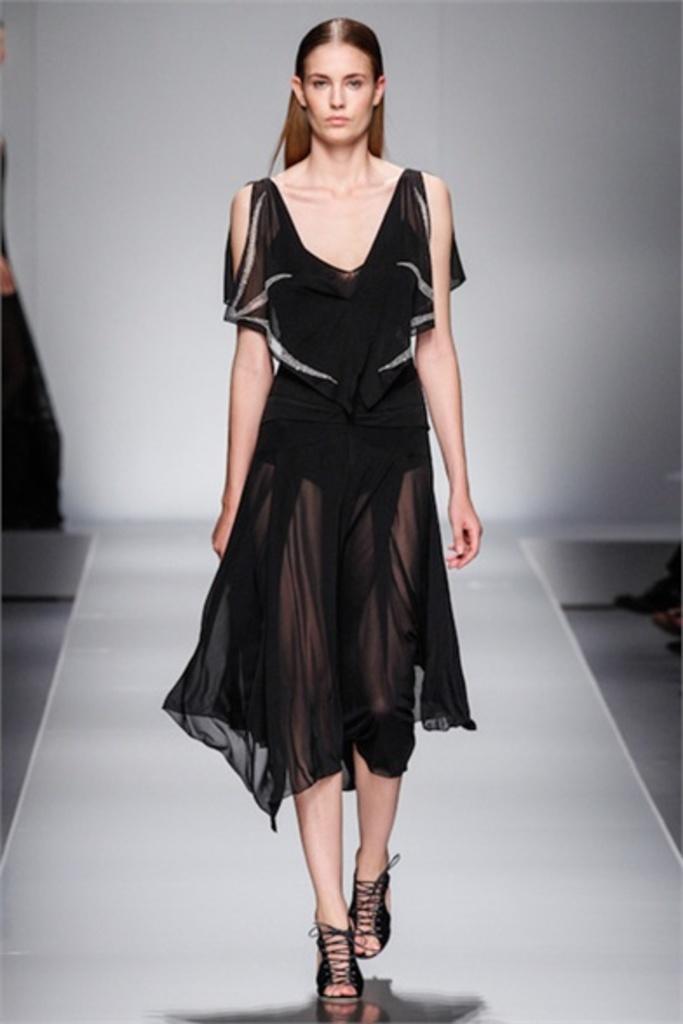Describe this image in one or two sentences. In the center of the image we can see a lady is walking on the ramp. In the background of the image we can see the wall, floor. On the right side of the image we can see some persons legs. On the left side of the image we can see a person. 